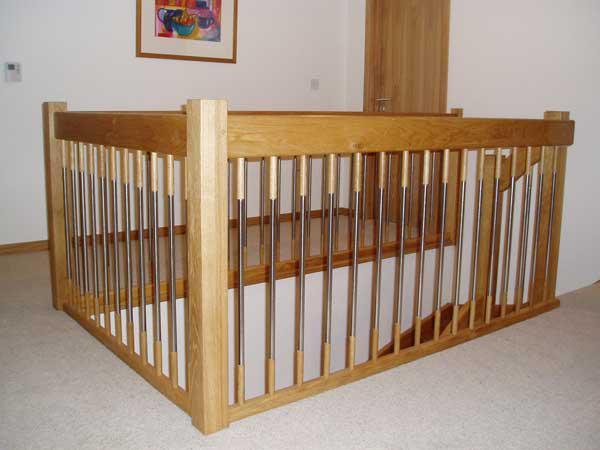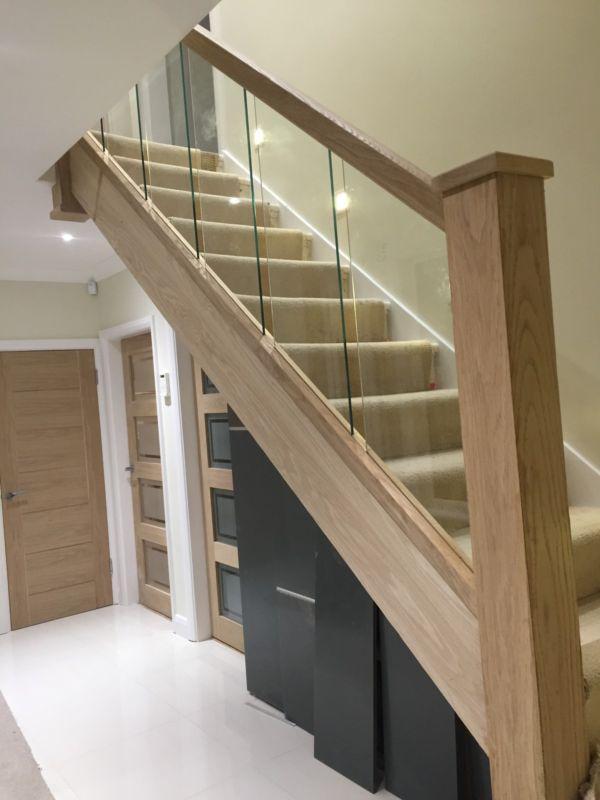The first image is the image on the left, the second image is the image on the right. For the images displayed, is the sentence "One image taken on an upper floor shows a brown wood handrail with vertical 'spindles' that goes around at least one side of a stairwell." factually correct? Answer yes or no. Yes. The first image is the image on the left, the second image is the image on the right. For the images displayed, is the sentence "Part of the stairway railing is made of glass." factually correct? Answer yes or no. Yes. 